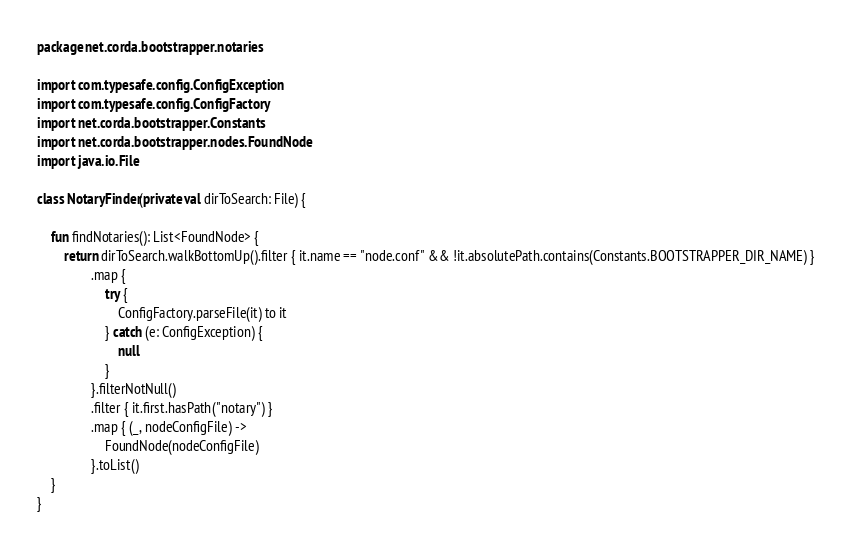Convert code to text. <code><loc_0><loc_0><loc_500><loc_500><_Kotlin_>package net.corda.bootstrapper.notaries

import com.typesafe.config.ConfigException
import com.typesafe.config.ConfigFactory
import net.corda.bootstrapper.Constants
import net.corda.bootstrapper.nodes.FoundNode
import java.io.File

class NotaryFinder(private val dirToSearch: File) {

    fun findNotaries(): List<FoundNode> {
        return dirToSearch.walkBottomUp().filter { it.name == "node.conf" && !it.absolutePath.contains(Constants.BOOTSTRAPPER_DIR_NAME) }
                .map {
                    try {
                        ConfigFactory.parseFile(it) to it
                    } catch (e: ConfigException) {
                        null
                    }
                }.filterNotNull()
                .filter { it.first.hasPath("notary") }
                .map { (_, nodeConfigFile) ->
                    FoundNode(nodeConfigFile)
                }.toList()
    }
}

</code> 